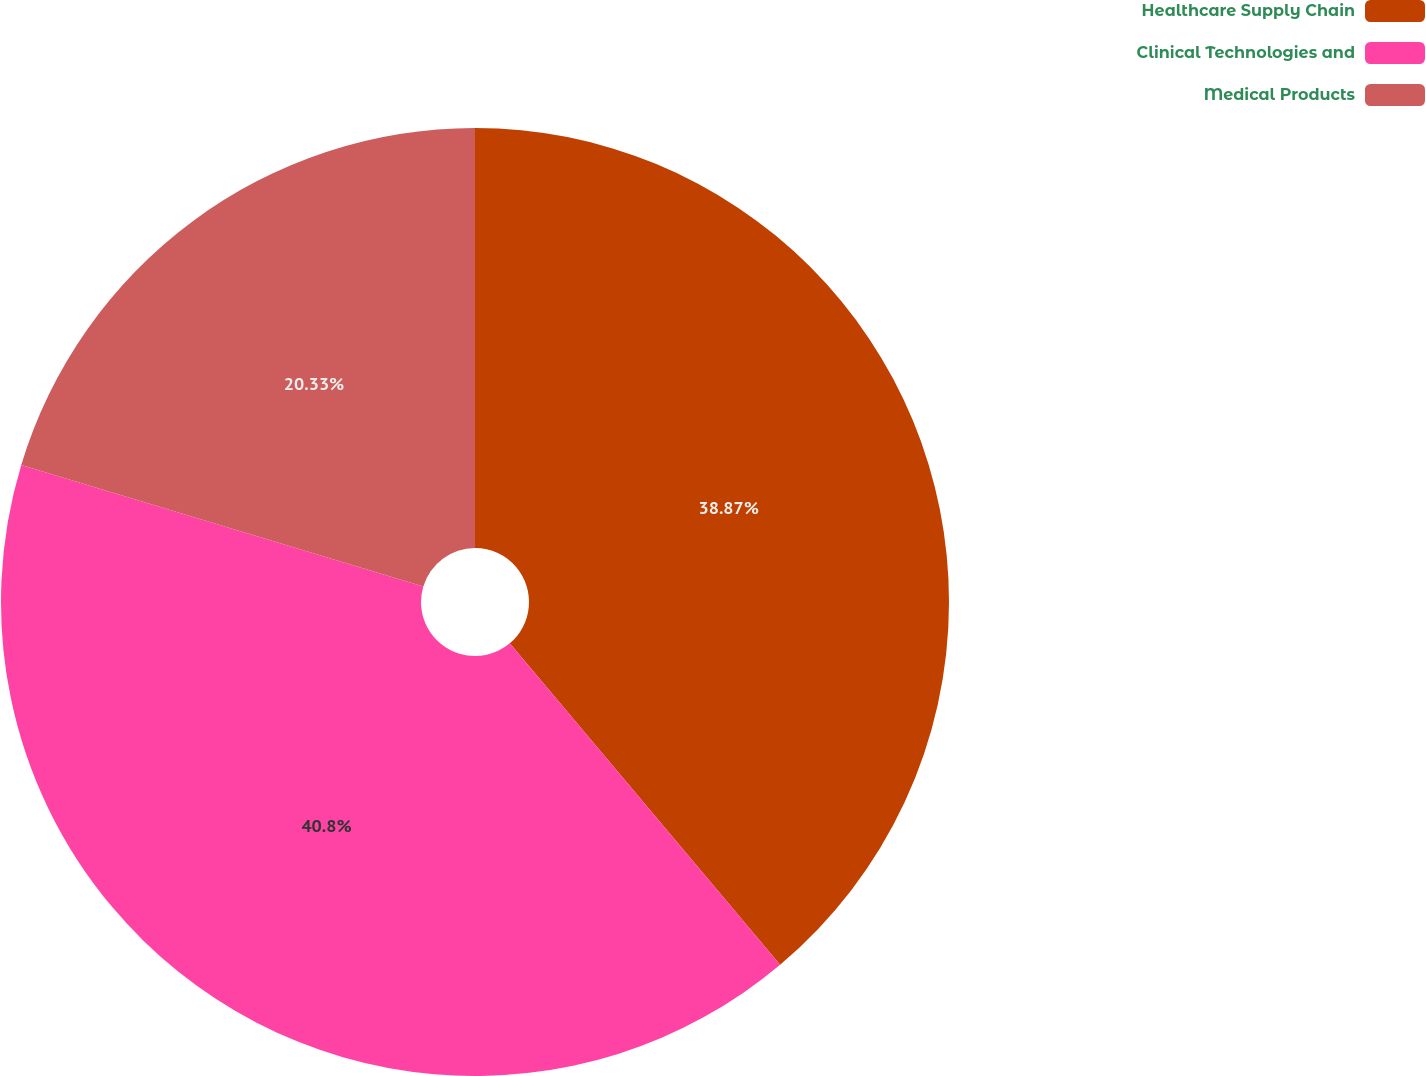Convert chart to OTSL. <chart><loc_0><loc_0><loc_500><loc_500><pie_chart><fcel>Healthcare Supply Chain<fcel>Clinical Technologies and<fcel>Medical Products<nl><fcel>38.87%<fcel>40.8%<fcel>20.33%<nl></chart> 